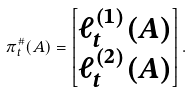Convert formula to latex. <formula><loc_0><loc_0><loc_500><loc_500>\pi _ { t } ^ { \# } ( A ) = \begin{bmatrix} \ell ^ { ( 1 ) } _ { t } ( A ) \\ \ell ^ { ( 2 ) } _ { t } ( A ) \end{bmatrix} .</formula> 